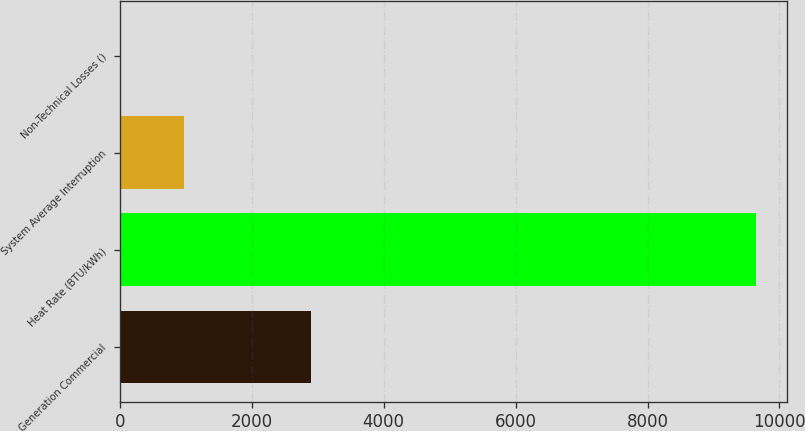<chart> <loc_0><loc_0><loc_500><loc_500><bar_chart><fcel>Generation Commercial<fcel>Heat Rate (BTU/kWh)<fcel>System Average Interruption<fcel>Non-Technical Losses ()<nl><fcel>2893.17<fcel>9638<fcel>966.07<fcel>2.52<nl></chart> 